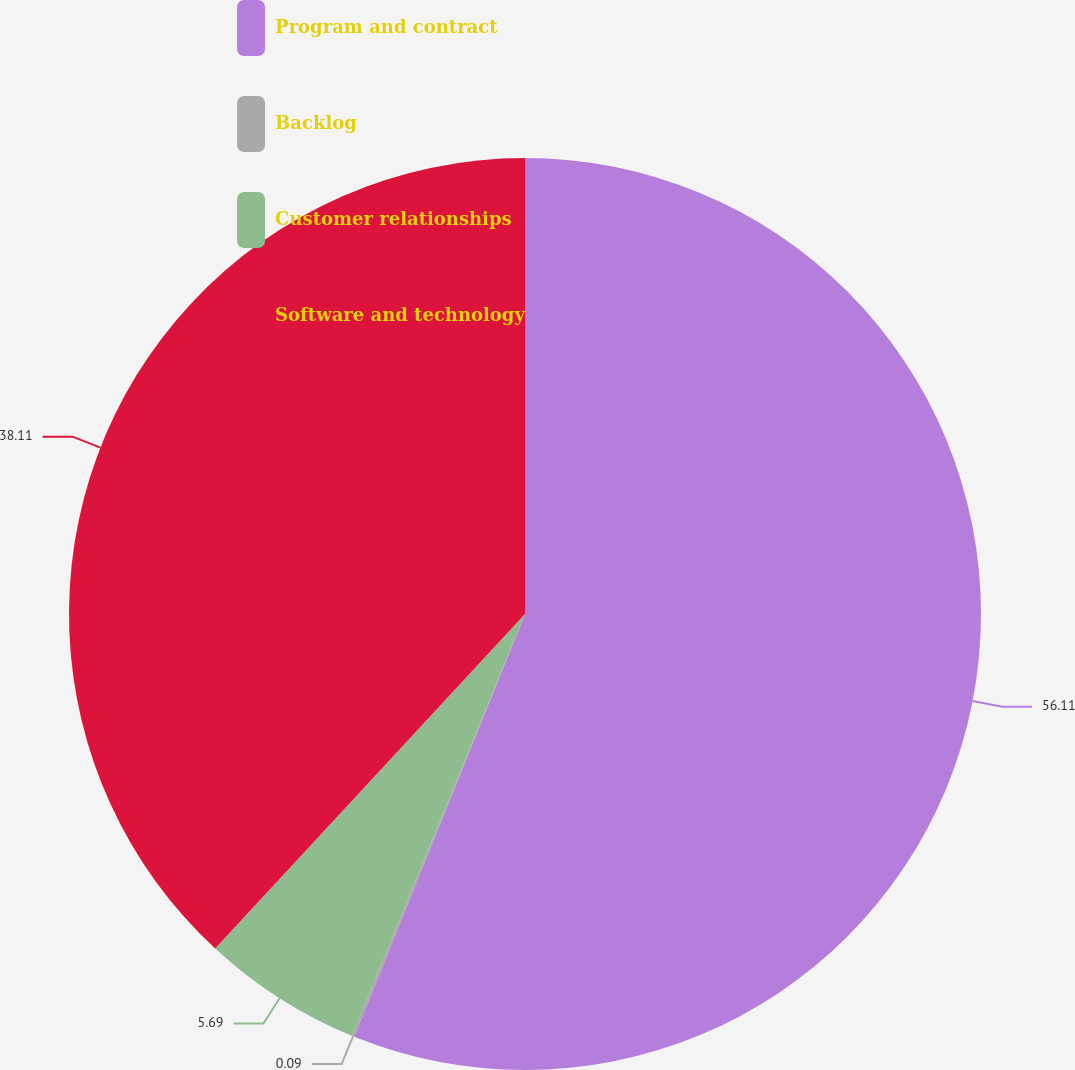<chart> <loc_0><loc_0><loc_500><loc_500><pie_chart><fcel>Program and contract<fcel>Backlog<fcel>Customer relationships<fcel>Software and technology<nl><fcel>56.11%<fcel>0.09%<fcel>5.69%<fcel>38.11%<nl></chart> 